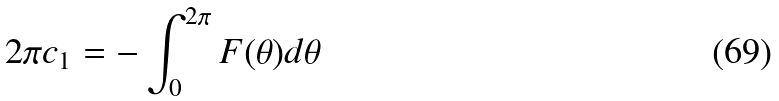Convert formula to latex. <formula><loc_0><loc_0><loc_500><loc_500>2 \pi c _ { 1 } = - \int _ { 0 } ^ { 2 \pi } F ( \theta ) d \theta</formula> 